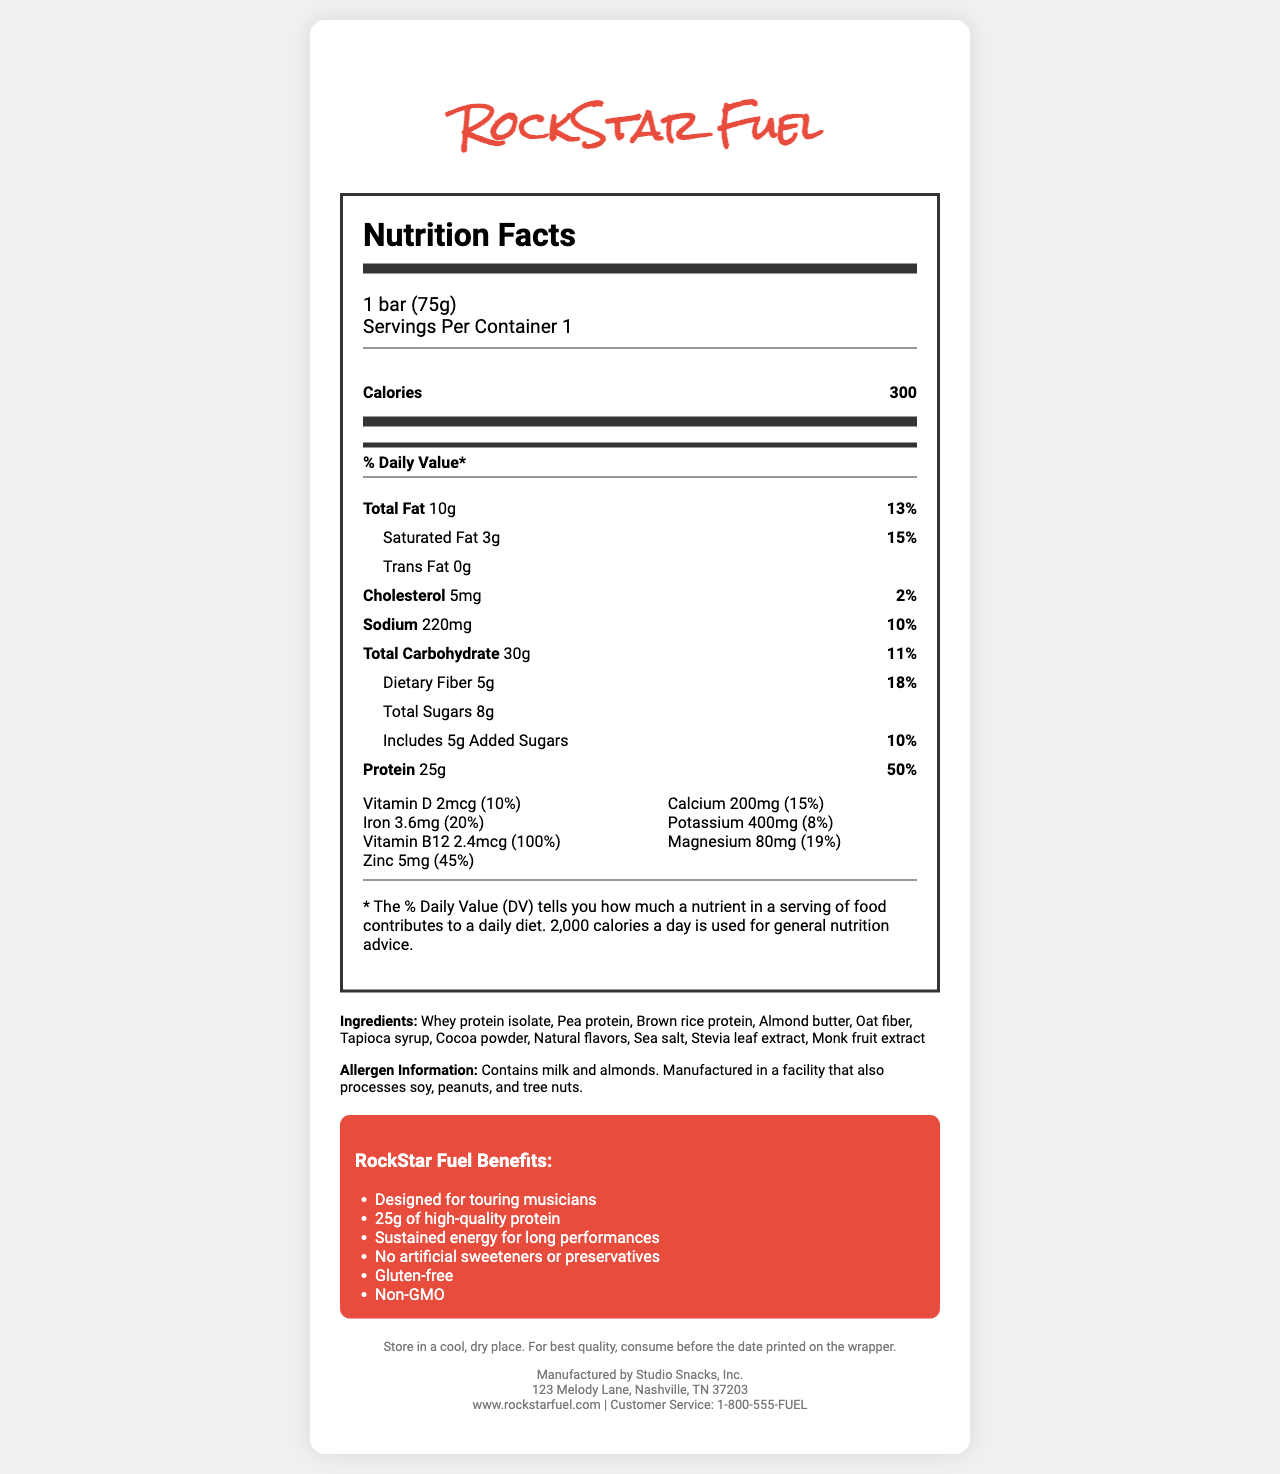what is the name of the product? The name of the product is prominently displayed at the top of the document.
Answer: RockStar Fuel what is the serving size of the bar? The serving size is listed in the serving information section.
Answer: 1 bar (75g) how many calories does the bar contain? The number of calories is highlighted in the main nutrient section.
Answer: 300 how much total fat is in one serving of RockStar Fuel? The amount of total fat is listed in the nutrient details.
Answer: 10g what is the daily value percentage for dietary fiber? The daily value percentage for dietary fiber is noted next to its amount.
Answer: 18% how much protein is in RockStar Fuel? A. 15g B. 20g C. 25g D. 30g The amount of protein is listed as 25g in the nutrient details.
Answer: C which vitamin or mineral has the highest percentage of daily value in RockStar Fuel? A. Vitamin D B. Calcium C. Vitamin B12 D. Magnesium Vitamin B12 has 100% daily value, which is the highest listed in the nutrient details.
Answer: C is RockStar Fuel gluten-free? The marketing claims state that RockStar Fuel is gluten-free.
Answer: Yes describe the main benefits of RockStar Fuel as mentioned in the document. The document outlines these benefits under the marketing claims section.
Answer: RockStar Fuel is designed for touring musicians, provides 25g of high-quality protein, offers sustained energy for long performances, contains no artificial sweeteners or preservatives, and is gluten-free and non-GMO. where is RockStar Fuel manufactured? The manufacturer's address is provided at the bottom of the document.
Answer: 123 Melody Lane, Nashville, TN 37203 what are the main ingredients in RockStar Fuel? The ingredients are listed in the ingredients section of the document.
Answer: Whey protein isolate, Pea protein, Brown rice protein, Almond butter, Oat fiber, Tapioca syrup, Cocoa powder, Natural flavors, Sea salt, Stevia leaf extract, Monk fruit extract how much added sugar is in the bar? The amount of added sugars is listed as 5g.
Answer: 5g can the allergen information help determine if there is soy in the product? The allergen information states that the product is manufactured in a facility that processes soy, but does not confirm if soy is an ingredient in the bar itself.
Answer: Not enough information who is the manufacturer of RockStar Fuel? The manufacturer's name is provided at the bottom of the document.
Answer: Studio Snacks, Inc. how much vitamin D is in RockStar Fuel? The amount of vitamin D is listed in the vitamin and minerals section.
Answer: 2mcg does RockStar Fuel contain any artificial sweeteners? The marketing claims specifically mention that there are no artificial sweeteners in RockStar Fuel.
Answer: No 